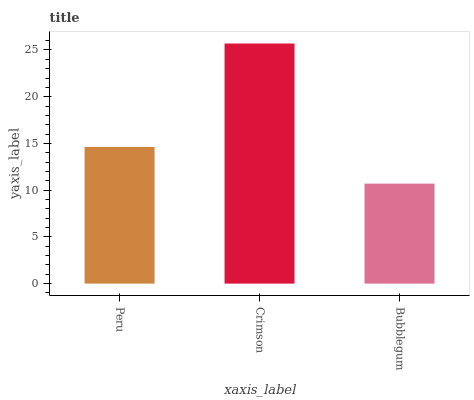Is Bubblegum the minimum?
Answer yes or no. Yes. Is Crimson the maximum?
Answer yes or no. Yes. Is Crimson the minimum?
Answer yes or no. No. Is Bubblegum the maximum?
Answer yes or no. No. Is Crimson greater than Bubblegum?
Answer yes or no. Yes. Is Bubblegum less than Crimson?
Answer yes or no. Yes. Is Bubblegum greater than Crimson?
Answer yes or no. No. Is Crimson less than Bubblegum?
Answer yes or no. No. Is Peru the high median?
Answer yes or no. Yes. Is Peru the low median?
Answer yes or no. Yes. Is Bubblegum the high median?
Answer yes or no. No. Is Crimson the low median?
Answer yes or no. No. 